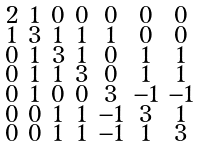Convert formula to latex. <formula><loc_0><loc_0><loc_500><loc_500>\begin{smallmatrix} 2 & 1 & 0 & 0 & 0 & 0 & 0 \\ 1 & 3 & 1 & 1 & 1 & 0 & 0 \\ 0 & 1 & 3 & 1 & 0 & 1 & 1 \\ 0 & 1 & 1 & 3 & 0 & 1 & 1 \\ 0 & 1 & 0 & 0 & 3 & - 1 & - 1 \\ 0 & 0 & 1 & 1 & - 1 & 3 & 1 \\ 0 & 0 & 1 & 1 & - 1 & 1 & 3 \end{smallmatrix}</formula> 